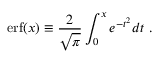<formula> <loc_0><loc_0><loc_500><loc_500>e r f ( x ) \equiv \frac { 2 } { \sqrt { \pi } } \int _ { 0 } ^ { x } e ^ { - t ^ { 2 } } d t \ .</formula> 